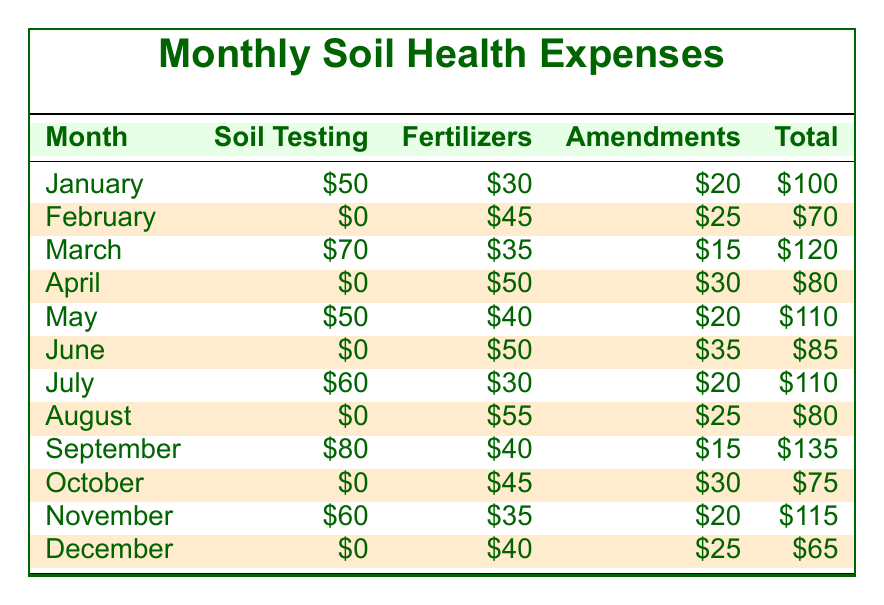What is the total expense for July? The total expense for July is directly listed in the table as $110.
Answer: 110 What is the total amount spent on soil testing over the year? To find the total spent on soil testing, we add the values from each month: 50 + 0 + 70 + 0 + 50 + 0 + 60 + 0 + 80 + 0 + 60 + 0 = 310.
Answer: 310 Which month had the highest expense on fertilizers? By examining the fertilizers column, the highest expense is in September with $40.
Answer: September What is the average total expense per month? We sum the total expenses for all months: 100 + 70 + 120 + 80 + 110 + 85 + 110 + 80 + 135 + 75 + 115 + 65 = 1,215. There are 12 months, so the average expense is 1215 / 12 = 101.25.
Answer: 101.25 Did any month have an expense of $0 for the total? Checking the total expenses for each month, February, April, June, August, October, and December all show a total expense of $0.
Answer: Yes 